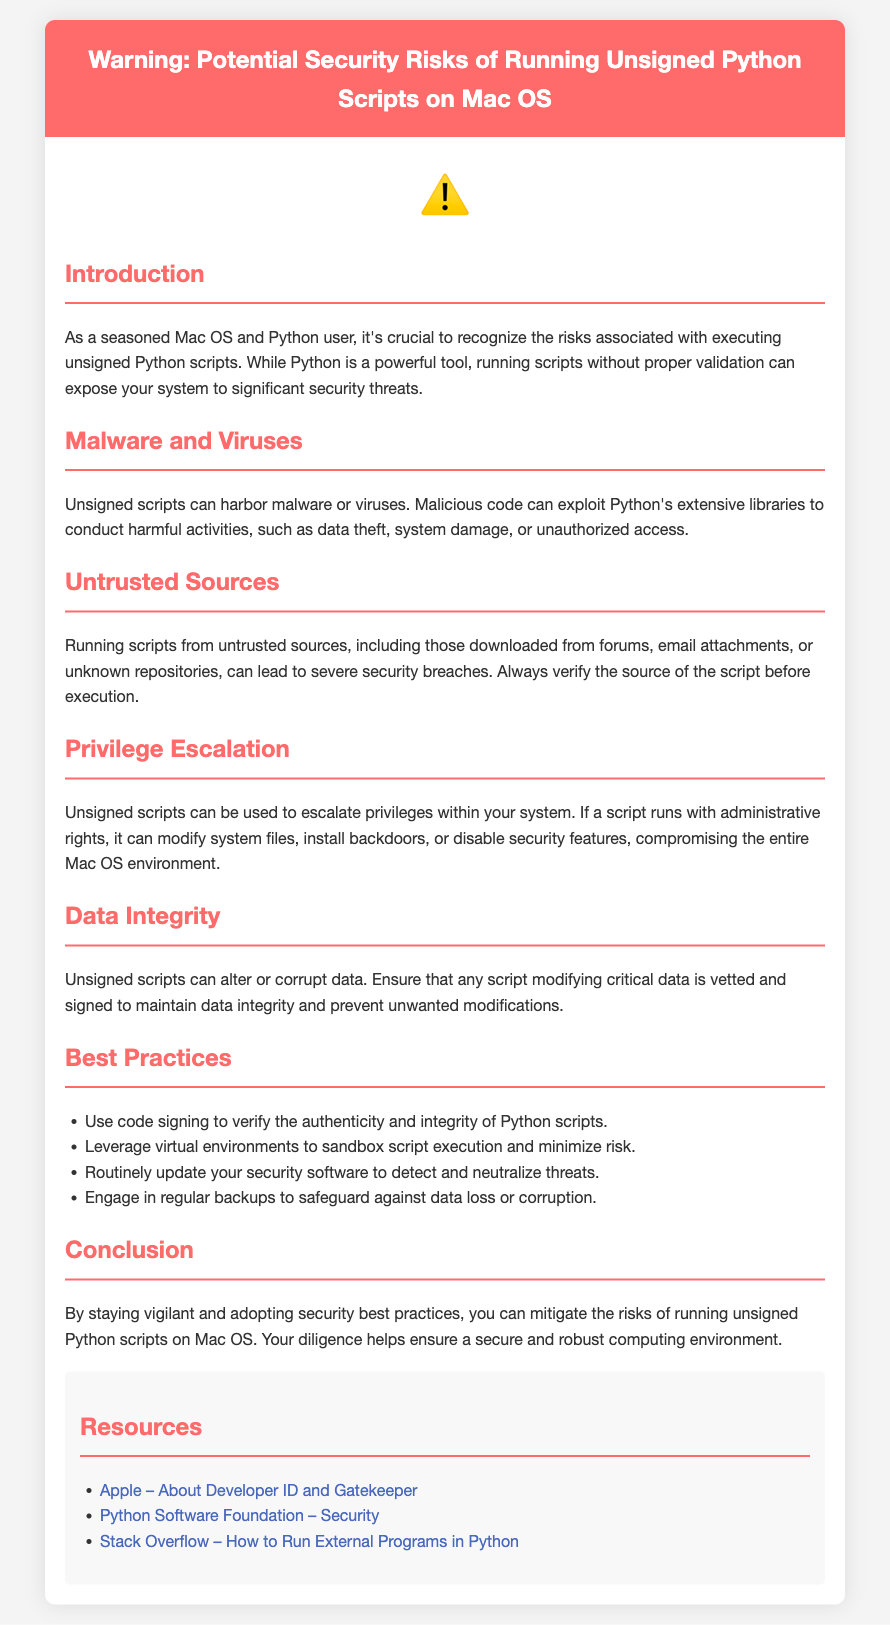What are the potential risks of running unsigned Python scripts? The document outlines several risks including malware, untrusted sources, privilege escalation, and data integrity issues.
Answer: Malware, untrusted sources, privilege escalation, data integrity What is a recommended practice for running Python scripts? The document suggests using code signing to verify the authenticity and integrity of Python scripts as a best practice.
Answer: Code signing What is the icon used in the document to signify a warning? A warning icon is displayed prominently in the document, which is a standard symbol used to convey caution.
Answer: ⚠️ How can unsigned scripts affect data? The document emphasizes that unsigned scripts can alter or corrupt data, impacting data integrity.
Answer: Alter or corrupt data What does privilege escalation allow an unsigned script to do? It allows the script to modify system files, install backdoors, or disable security features within the system.
Answer: Modify system files, install backdoors, disable security features What should you routinely update according to the best practices? The document recommends routinely updating security software to detect and neutralize threats.
Answer: Security software Where can additional resources about security be found? The document provides links to additional resources including an Apple support page and Python Software Foundation’s security documentation.
Answer: Additional resources What does the document recommend to safeguard against data loss? It suggests engaging in regular backups as a way to protect against data loss or corruption.
Answer: Regular backups 